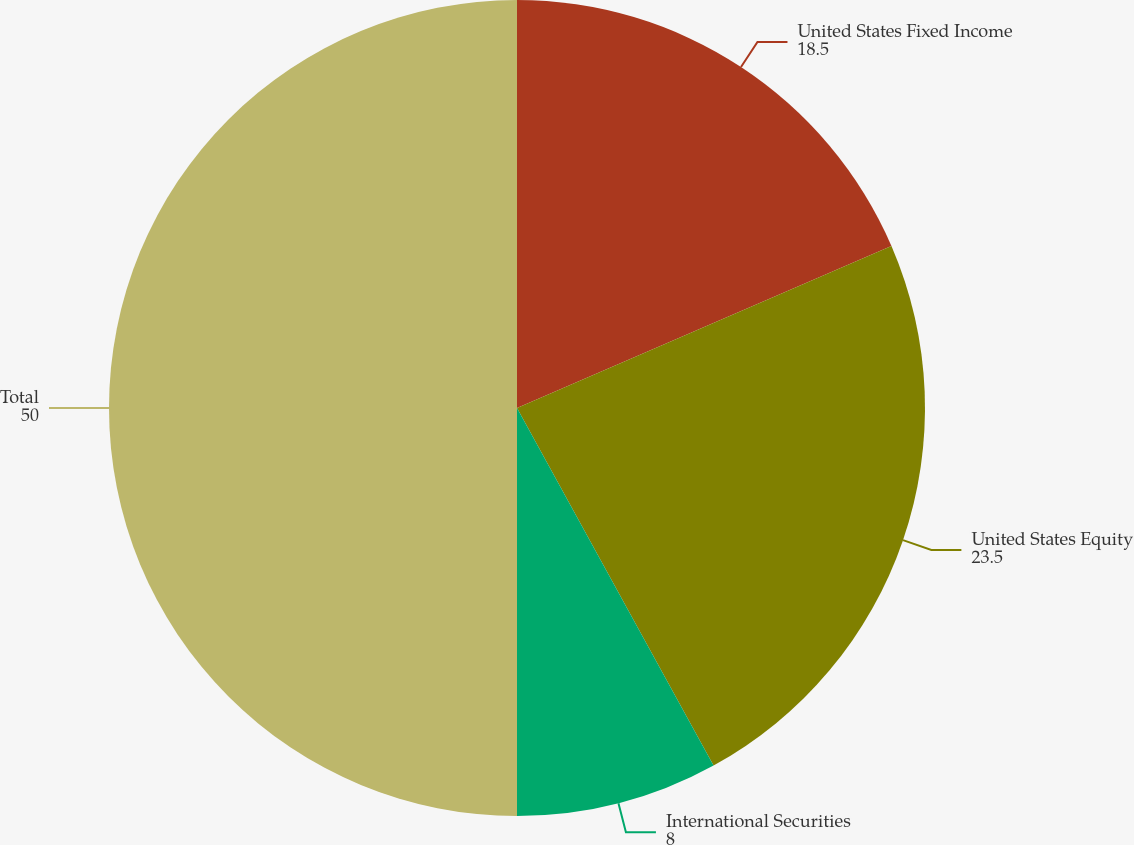<chart> <loc_0><loc_0><loc_500><loc_500><pie_chart><fcel>United States Fixed Income<fcel>United States Equity<fcel>International Securities<fcel>Total<nl><fcel>18.5%<fcel>23.5%<fcel>8.0%<fcel>50.0%<nl></chart> 